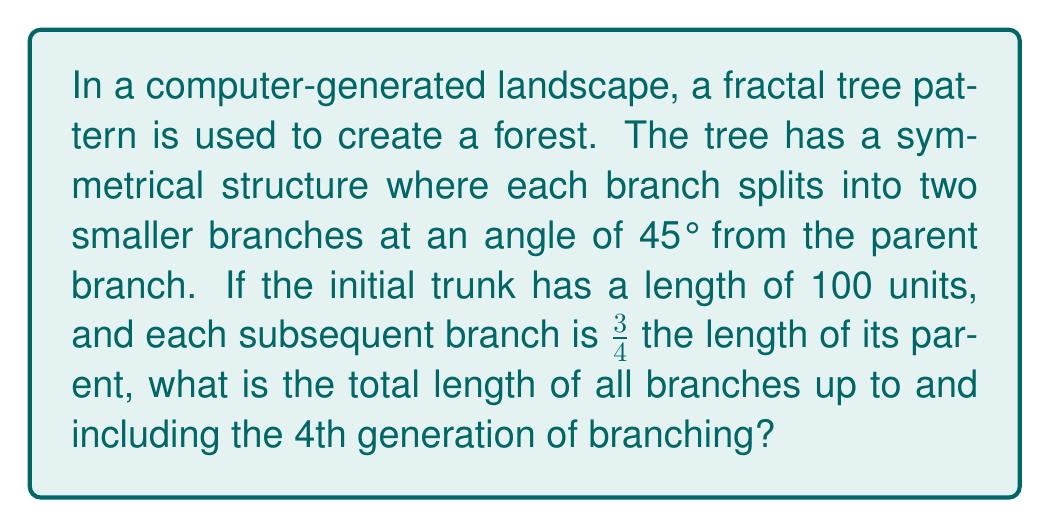Can you solve this math problem? Let's approach this step-by-step:

1) First, let's define our generations:
   - Generation 0: The trunk (1 branch)
   - Generation 1: First split (2 branches)
   - Generation 2: Second split (4 branches)
   - Generation 3: Third split (8 branches)
   - Generation 4: Fourth split (16 branches)

2) Now, let's calculate the length of branches in each generation:
   - Gen 0: $l_0 = 100$ units
   - Gen 1: $l_1 = 100 \times \frac{3}{4} = 75$ units
   - Gen 2: $l_2 = 75 \times \frac{3}{4} = 56.25$ units
   - Gen 3: $l_3 = 56.25 \times \frac{3}{4} = 42.1875$ units
   - Gen 4: $l_4 = 42.1875 \times \frac{3}{4} = 31.640625$ units

3) Now, let's calculate the total length for each generation:
   - Gen 0: $T_0 = 1 \times 100 = 100$ units
   - Gen 1: $T_1 = 2 \times 75 = 150$ units
   - Gen 2: $T_2 = 4 \times 56.25 = 225$ units
   - Gen 3: $T_3 = 8 \times 42.1875 = 337.5$ units
   - Gen 4: $T_4 = 16 \times 31.640625 = 506.25$ units

4) The total length of all branches up to and including the 4th generation is the sum of all these:

   $$T_{total} = T_0 + T_1 + T_2 + T_3 + T_4$$
   $$T_{total} = 100 + 150 + 225 + 337.5 + 506.25$$
   $$T_{total} = 1318.75 \text{ units}$$

This fractal pattern demonstrates rotational symmetry, as each subtree is a rotated and scaled version of the whole tree. It also exhibits self-similarity, a key feature of fractals in computer-generated landscapes.
Answer: The total length of all branches up to and including the 4th generation is 1318.75 units. 